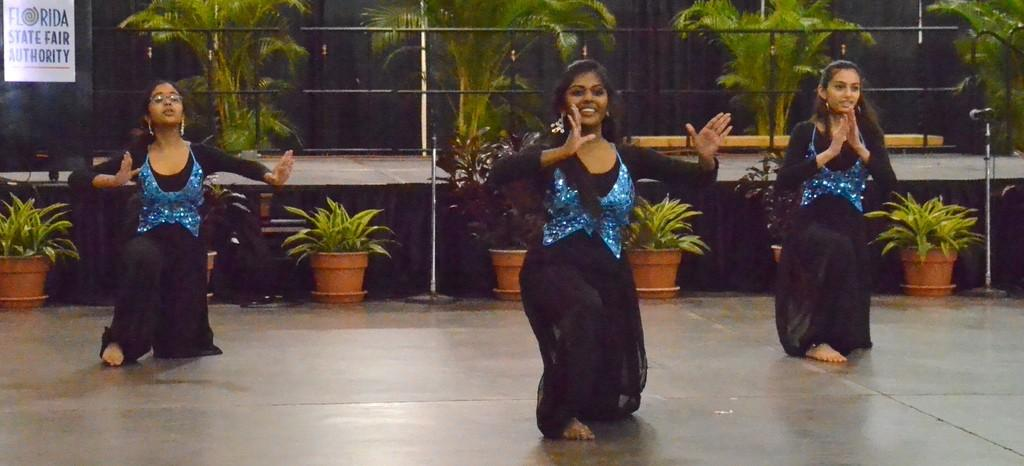What are the girls in the image doing? The girls are dancing in the image. What can be seen in the background behind the girls? There are pots with plants, trees, railings, and mic stands in the background. Are there any musical instruments or equipment visible in the image? Yes, there is a mic stand with a mic on it in the background. What type of stone is being weighed on a scale in the image? There is no stone or scale present in the image. Can you tell me how many carts are visible in the image? There are no carts visible in the image. 